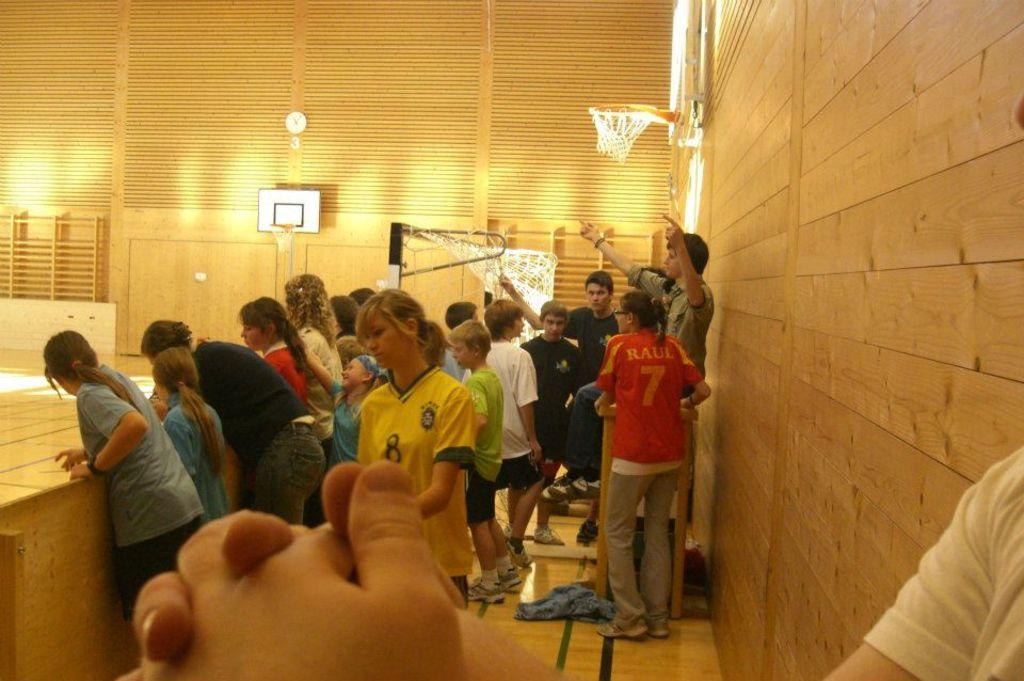What type of location is shown in the image? The image depicts a basketball court. Are there any people present in the image? Yes, there are people standing in the image. What is a feature of the basketball court that can be used to score points? There are basketball nets on the walls. What time-related object can be seen on the wall? There is a clock on the wall. What type of plants can be seen growing on the basketball court in the image? There are no plants visible on the basketball court in the image. What organization is responsible for maintaining the basketball court in the image? The image does not provide information about the organization responsible for maintaining the basketball court. 